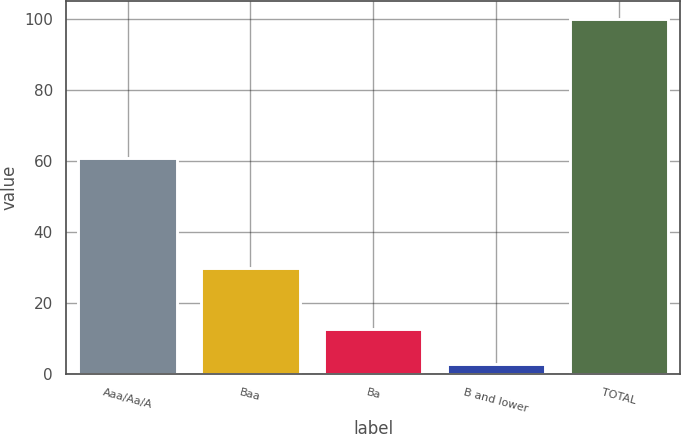<chart> <loc_0><loc_0><loc_500><loc_500><bar_chart><fcel>Aaa/Aa/A<fcel>Baa<fcel>Ba<fcel>B and lower<fcel>TOTAL<nl><fcel>61<fcel>30<fcel>12.7<fcel>3<fcel>100<nl></chart> 